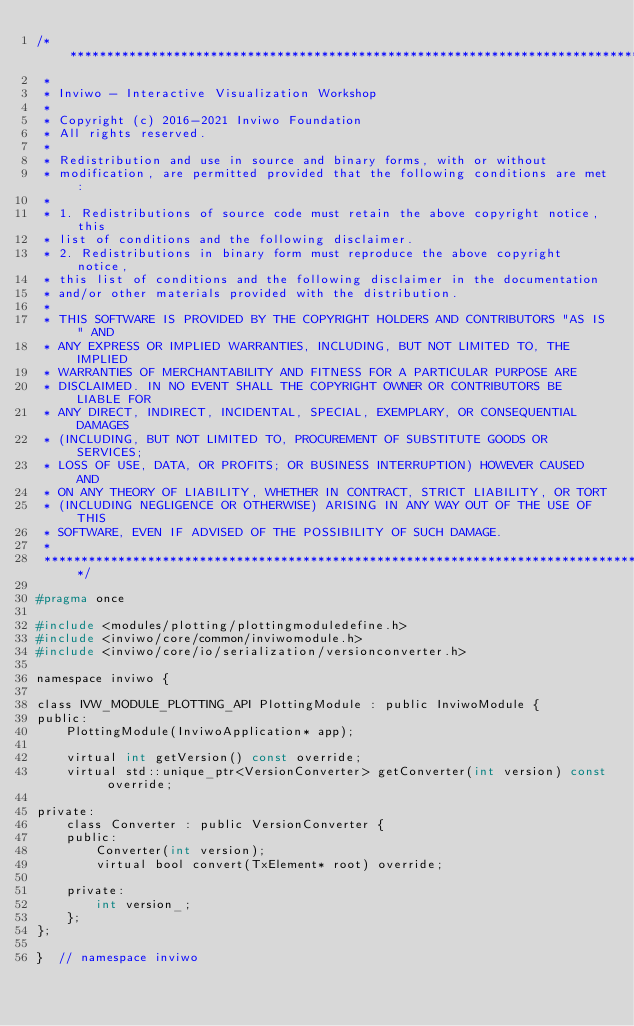Convert code to text. <code><loc_0><loc_0><loc_500><loc_500><_C_>/*********************************************************************************
 *
 * Inviwo - Interactive Visualization Workshop
 *
 * Copyright (c) 2016-2021 Inviwo Foundation
 * All rights reserved.
 *
 * Redistribution and use in source and binary forms, with or without
 * modification, are permitted provided that the following conditions are met:
 *
 * 1. Redistributions of source code must retain the above copyright notice, this
 * list of conditions and the following disclaimer.
 * 2. Redistributions in binary form must reproduce the above copyright notice,
 * this list of conditions and the following disclaimer in the documentation
 * and/or other materials provided with the distribution.
 *
 * THIS SOFTWARE IS PROVIDED BY THE COPYRIGHT HOLDERS AND CONTRIBUTORS "AS IS" AND
 * ANY EXPRESS OR IMPLIED WARRANTIES, INCLUDING, BUT NOT LIMITED TO, THE IMPLIED
 * WARRANTIES OF MERCHANTABILITY AND FITNESS FOR A PARTICULAR PURPOSE ARE
 * DISCLAIMED. IN NO EVENT SHALL THE COPYRIGHT OWNER OR CONTRIBUTORS BE LIABLE FOR
 * ANY DIRECT, INDIRECT, INCIDENTAL, SPECIAL, EXEMPLARY, OR CONSEQUENTIAL DAMAGES
 * (INCLUDING, BUT NOT LIMITED TO, PROCUREMENT OF SUBSTITUTE GOODS OR SERVICES;
 * LOSS OF USE, DATA, OR PROFITS; OR BUSINESS INTERRUPTION) HOWEVER CAUSED AND
 * ON ANY THEORY OF LIABILITY, WHETHER IN CONTRACT, STRICT LIABILITY, OR TORT
 * (INCLUDING NEGLIGENCE OR OTHERWISE) ARISING IN ANY WAY OUT OF THE USE OF THIS
 * SOFTWARE, EVEN IF ADVISED OF THE POSSIBILITY OF SUCH DAMAGE.
 *
 *********************************************************************************/

#pragma once

#include <modules/plotting/plottingmoduledefine.h>
#include <inviwo/core/common/inviwomodule.h>
#include <inviwo/core/io/serialization/versionconverter.h>

namespace inviwo {

class IVW_MODULE_PLOTTING_API PlottingModule : public InviwoModule {
public:
    PlottingModule(InviwoApplication* app);

    virtual int getVersion() const override;
    virtual std::unique_ptr<VersionConverter> getConverter(int version) const override;

private:
    class Converter : public VersionConverter {
    public:
        Converter(int version);
        virtual bool convert(TxElement* root) override;

    private:
        int version_;
    };
};

}  // namespace inviwo
</code> 